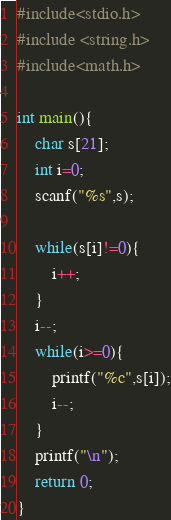Convert code to text. <code><loc_0><loc_0><loc_500><loc_500><_C_>#include<stdio.h>
#include <string.h>
#include<math.h>

int main(){
	char s[21];
	int i=0;
	scanf("%s",s);
	
	while(s[i]!=0){
		i++;
	}
	i--;
	while(i>=0){
		printf("%c",s[i]);
		i--;
	}
	printf("\n");
	return 0;
}</code> 